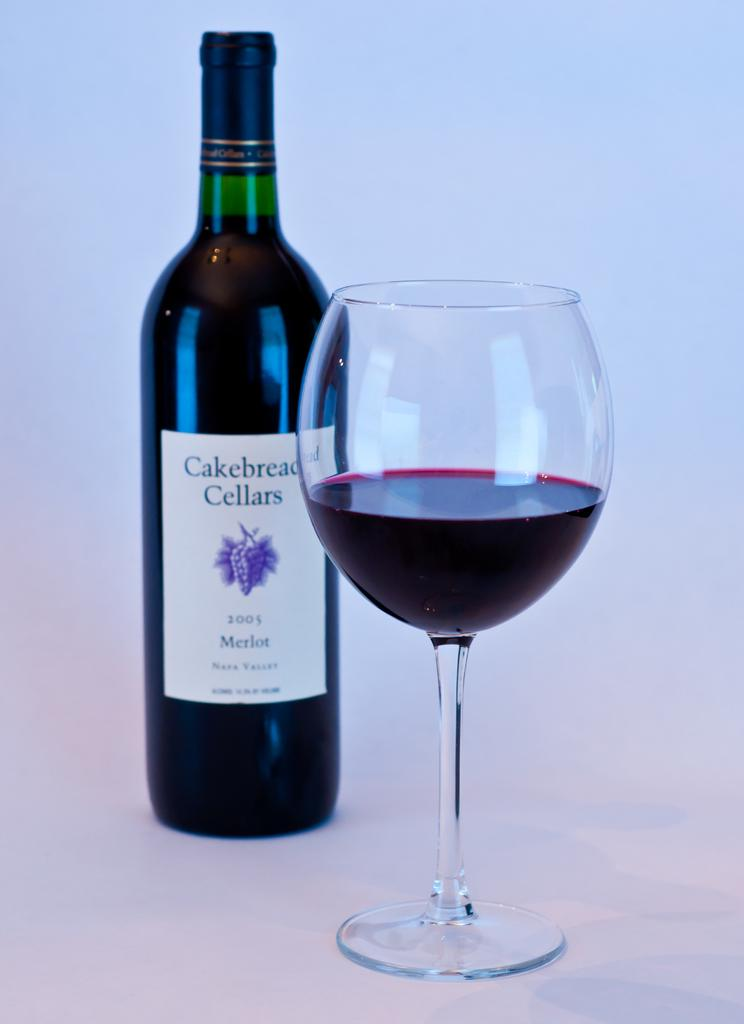What is the name of the glass bottle in the image? The glass bottle in the image is named "cakebread cellars." What is located beside the bottle in the image? There is a glass with juice beside the bottle in the image. What type of power source is used to create the juice in the glass? There is no information about the power source used to create the juice in the image. The image only shows a glass with juice beside the bottle. 